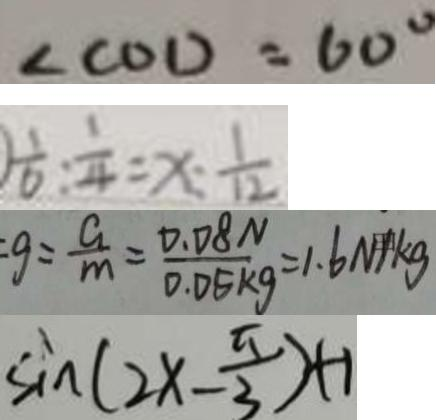<formula> <loc_0><loc_0><loc_500><loc_500>\angle C O D = 6 0 ^ { \circ } 
 ) \frac { 1 } { 6 } : \frac { 1 } { 4 } = x : \frac { 1 } { 1 2 } 
 g = \frac { G } { m } = \frac { 0 . 0 8 N } { 0 . 0 5 k g } = 1 . 6 N / k g 
 \sin ( 2 x - \frac { \pi } { 3 } ) + 1</formula> 